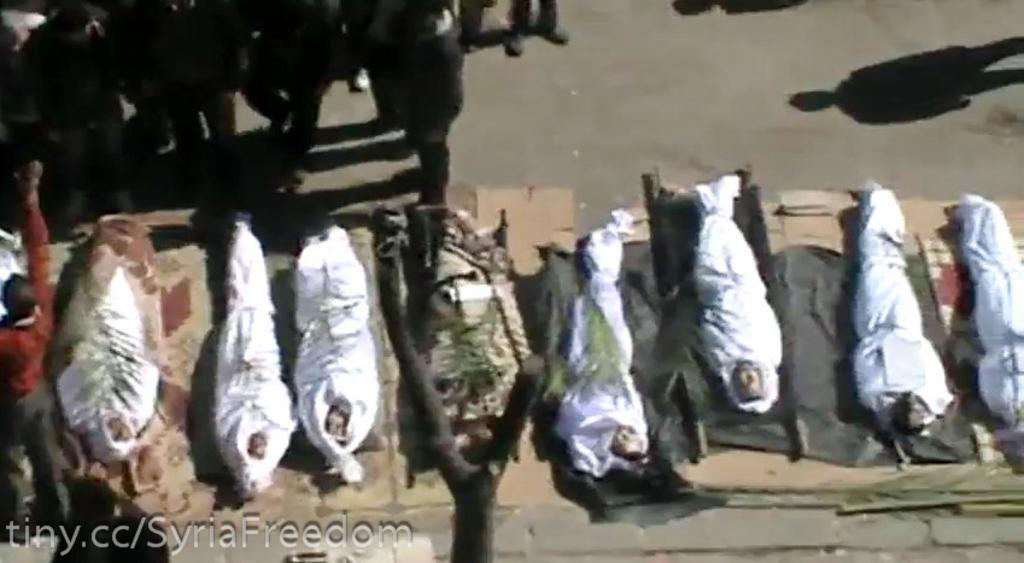What is happening in the image involving people? There are people standing on the ground in the image. What can be seen under the white clothes in the image? There is an object covered with white clothes in the image. Can you describe any additional details about the image? There are watermarks on the left bottom of the image. What shape is the person in the image? There is no person present in the image; it only shows people standing on the ground. What type of structure is visible under the white clothes in the image? There is no structure visible under the white clothes in the image; it only shows an object covered with white clothes. 